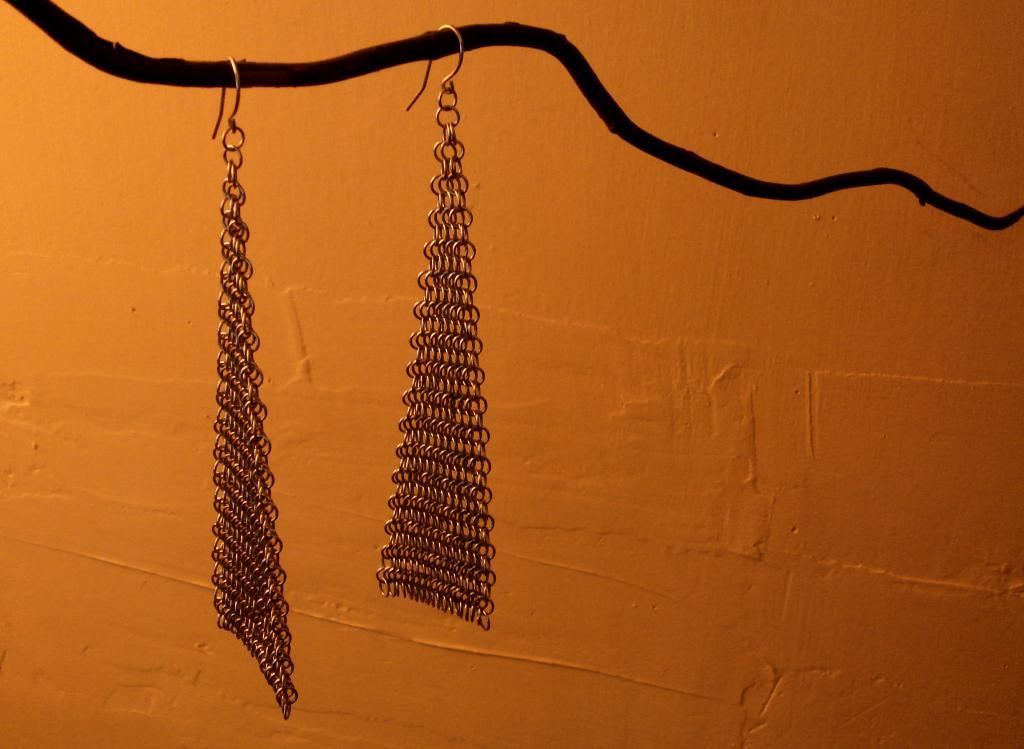What is hanging in the center of the image? There are earrings hanging in the center of the image. What can be seen in the background of the image? There is a wall visible in the background of the image. What type of butter is being spread on the rose in the image? There is no butter or rose present in the image; it only features earrings hanging in the center and a wall in the background. 